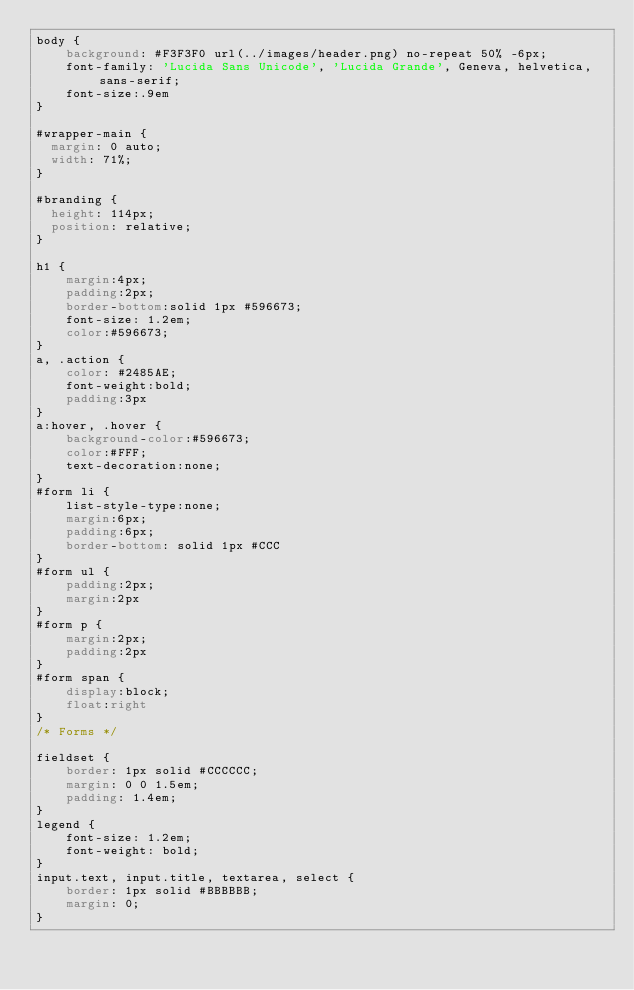<code> <loc_0><loc_0><loc_500><loc_500><_CSS_>body {
	background: #F3F3F0 url(../images/header.png) no-repeat 50% -6px;
	font-family: 'Lucida Sans Unicode', 'Lucida Grande', Geneva, helvetica, sans-serif;
	font-size:.9em
}

#wrapper-main {
  margin: 0 auto;
  width: 71%;
}

#branding {
  height: 114px;
  position: relative;
}

h1 {
	margin:4px;
	padding:2px;
	border-bottom:solid 1px #596673;
	font-size: 1.2em;
	color:#596673;
}
a, .action {
	color: #2485AE;
	font-weight:bold;
	padding:3px
}
a:hover, .hover {
	background-color:#596673;
	color:#FFF;
	text-decoration:none;
}
#form li {
	list-style-type:none;
	margin:6px;
	padding:6px;
	border-bottom: solid 1px #CCC
}
#form ul {
	padding:2px;
	margin:2px
}
#form p {
	margin:2px;
	padding:2px
}
#form span {
	display:block;
	float:right
}
/* Forms */

fieldset {
	border: 1px solid #CCCCCC;
	margin: 0 0 1.5em;
	padding: 1.4em;
}
legend {
	font-size: 1.2em;
	font-weight: bold;
}
input.text, input.title, textarea, select {
	border: 1px solid #BBBBBB;
	margin: 0;
}</code> 